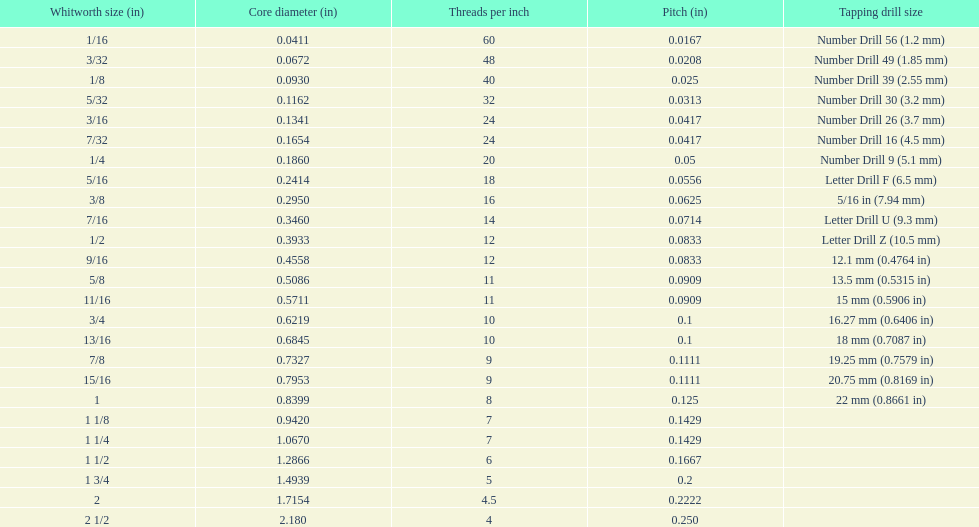Which whitworth size is the only one that has 5 threads per inch? 1 3/4. 